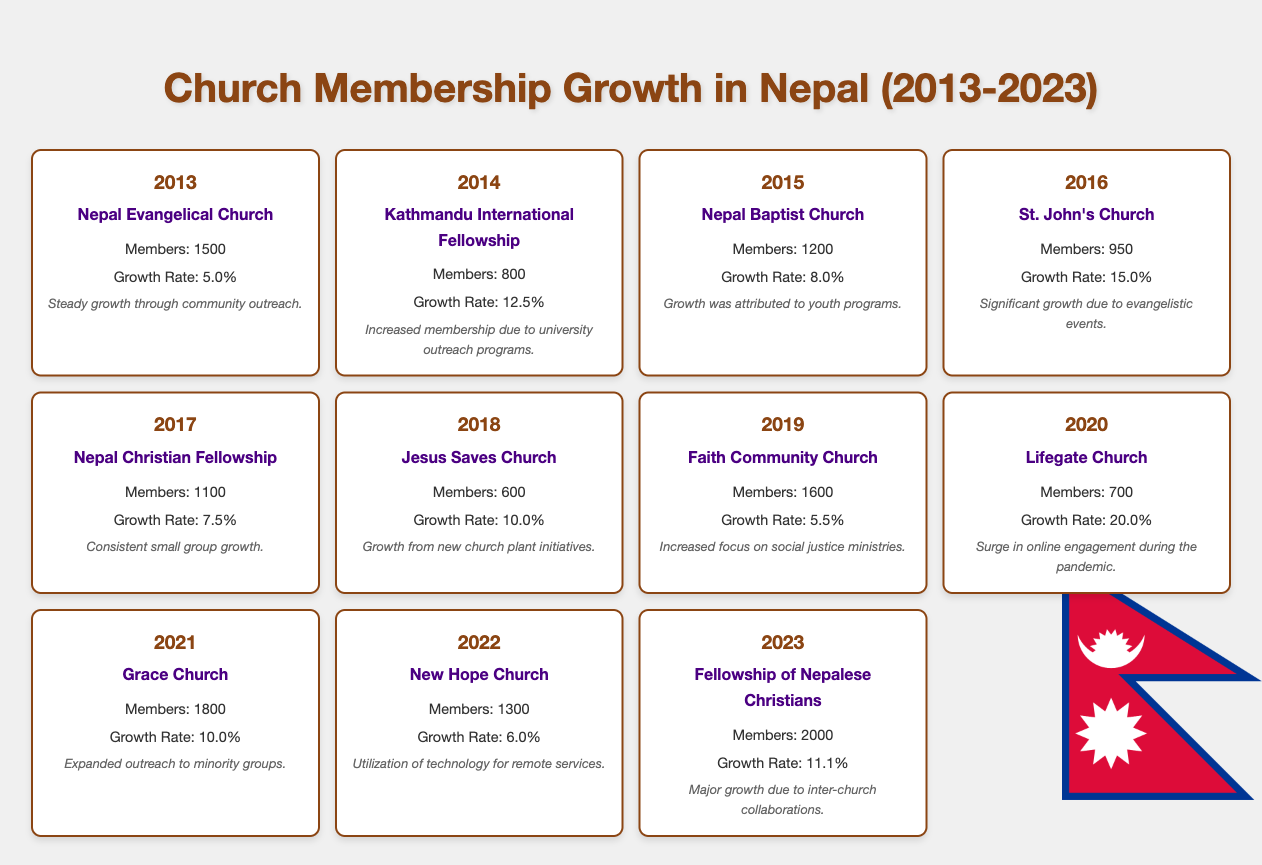What was the growth rate of the Nepal Evangelical Church in 2013? The table shows that the Nepal Evangelical Church had a growth rate of 5.0% in the year 2013.
Answer: 5.0% Which church had the highest number of members in 2023? In 2023, the Fellowship of Nepalese Christians had the highest membership at 2000 members, according to the table.
Answer: 2000 What is the total membership across all listed churches for 2021? Summing the members for each church in 2021: Grace Church (1800) + Lifegate Church (700) = 2500. So, the total membership for 2021 is 2500 members.
Answer: 2500 Did the Jesus Saves Church experience growth in membership every year from 2013 to 2023? According to the table, the Jesus Saves Church had members in 2018 (600), but there is no record for earlier years. Therefore, the statement cannot be definitively answered without additional data.
Answer: No What was the average growth rate across all churches from 2013 to 2023? To find the average growth rate, you sum the growth rates of all churches from 2013 (5.0) to 2023 (11.1) and divide by the number of years (11): (5.0 + 12.5 + 8.0 + 15.0 + 7.5 + 10.0 + 5.5 + 20.0 + 10.0 + 6.0 + 11.1) / 11 = 9.23.
Answer: 9.23 Which church had the largest growth rate and what year was it? The largest growth rate was for Lifegate Church in 2020, with a growth rate of 20.0%. This data point is extracted from the table.
Answer: 20.0% in 2020 